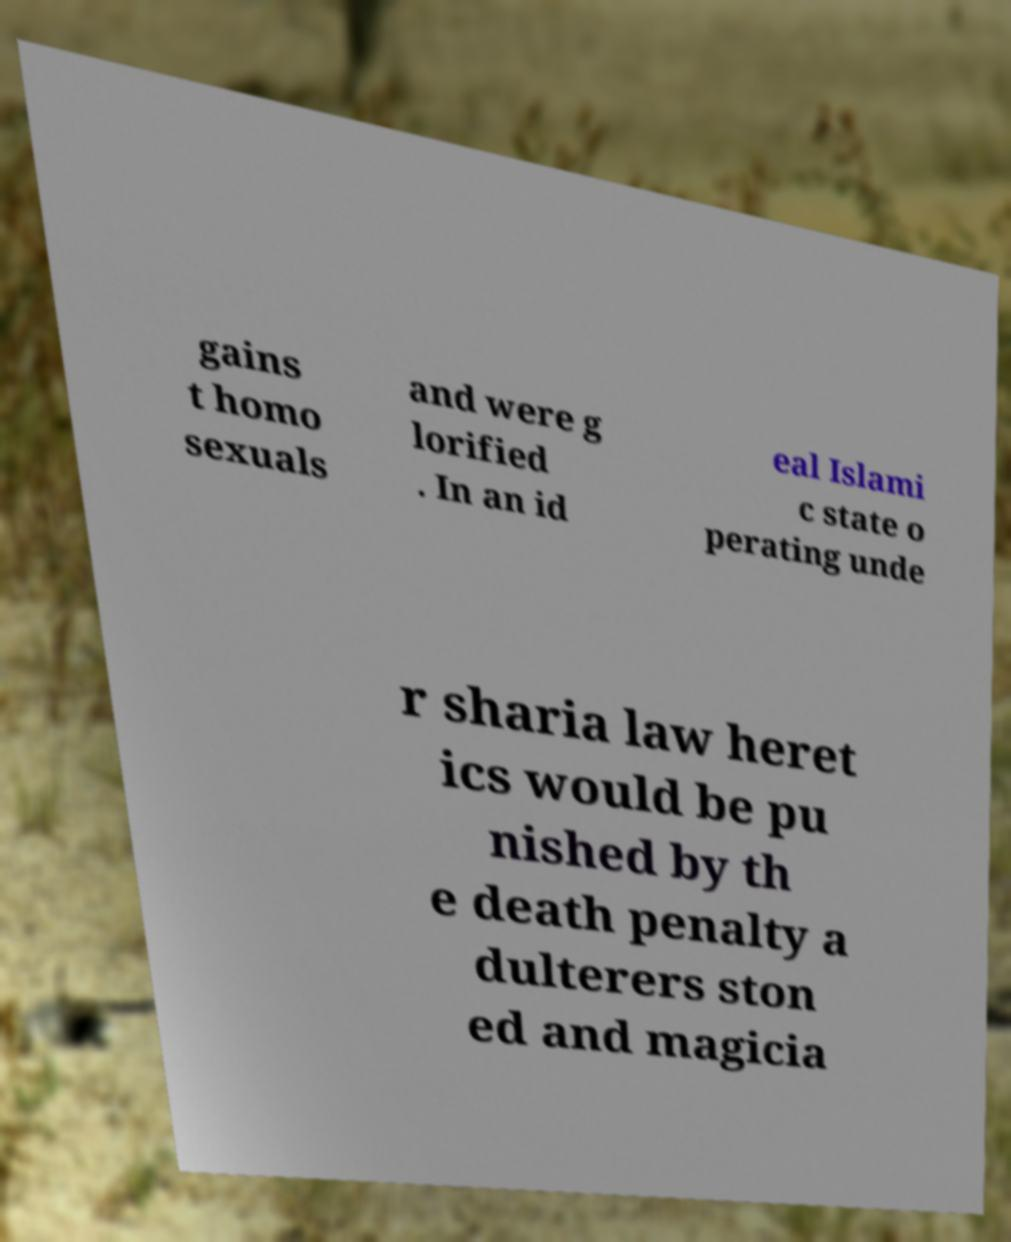For documentation purposes, I need the text within this image transcribed. Could you provide that? gains t homo sexuals and were g lorified . In an id eal Islami c state o perating unde r sharia law heret ics would be pu nished by th e death penalty a dulterers ston ed and magicia 